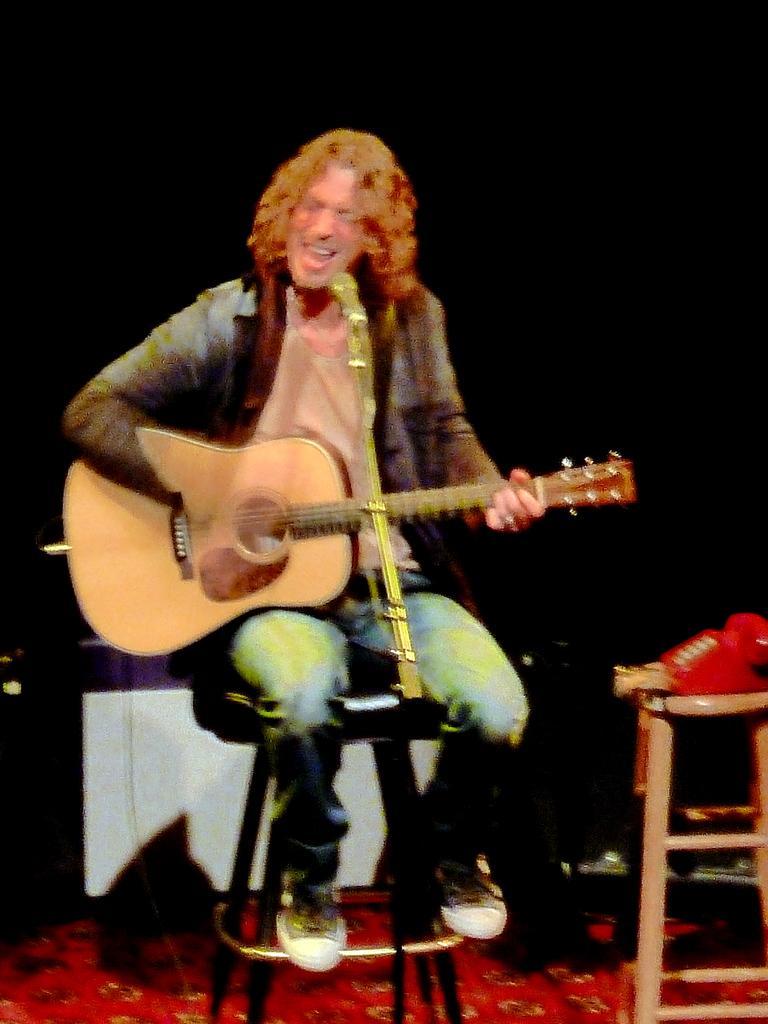Describe this image in one or two sentences. In this image I can see a person sitting in-front of the mic and holding the guitar. 